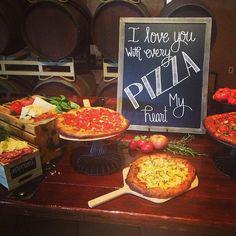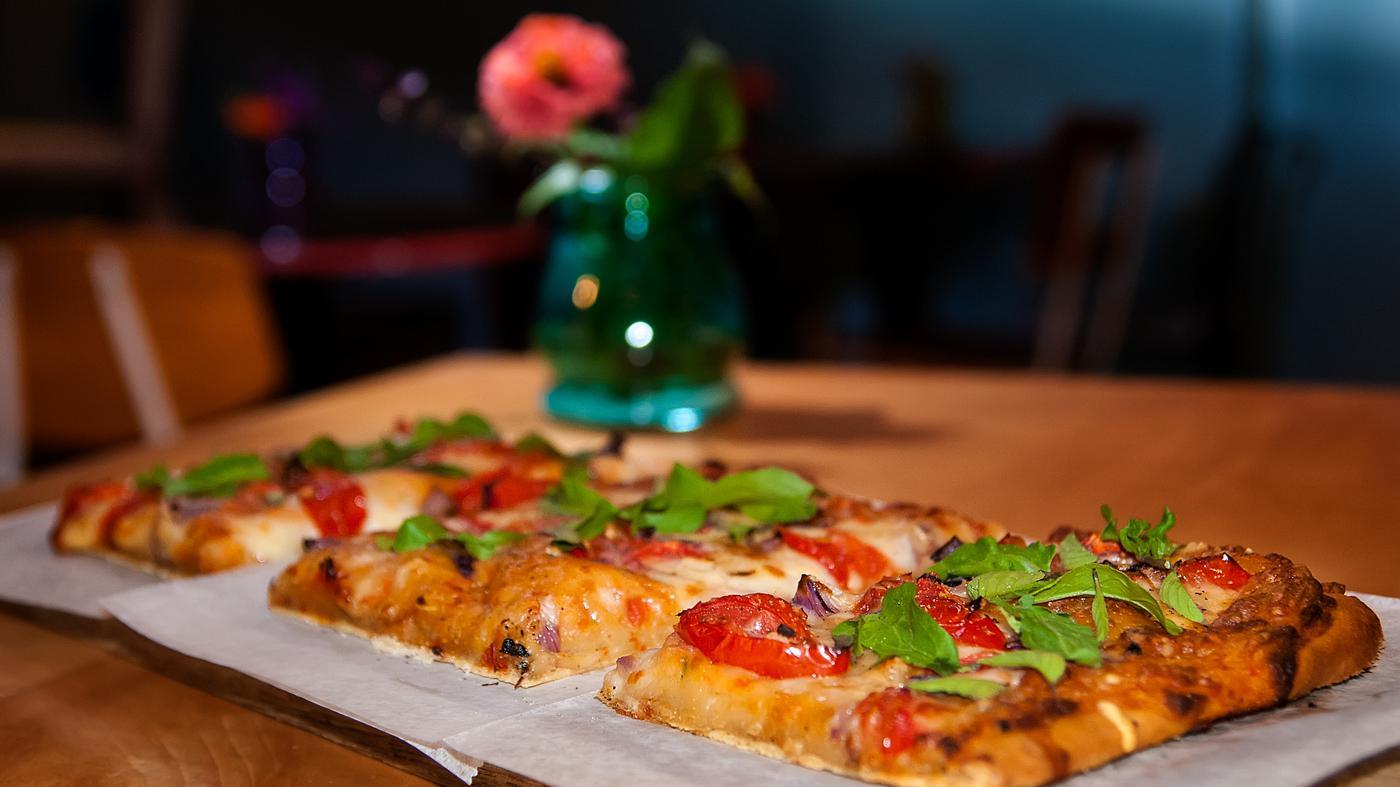The first image is the image on the left, the second image is the image on the right. Assess this claim about the two images: "In the image on the right, some pizzas are raised on stands.". Correct or not? Answer yes or no. No. The first image is the image on the left, the second image is the image on the right. Examine the images to the left and right. Is the description "A sign on the chalkboard is announcing the food on the table in one of the images." accurate? Answer yes or no. Yes. 